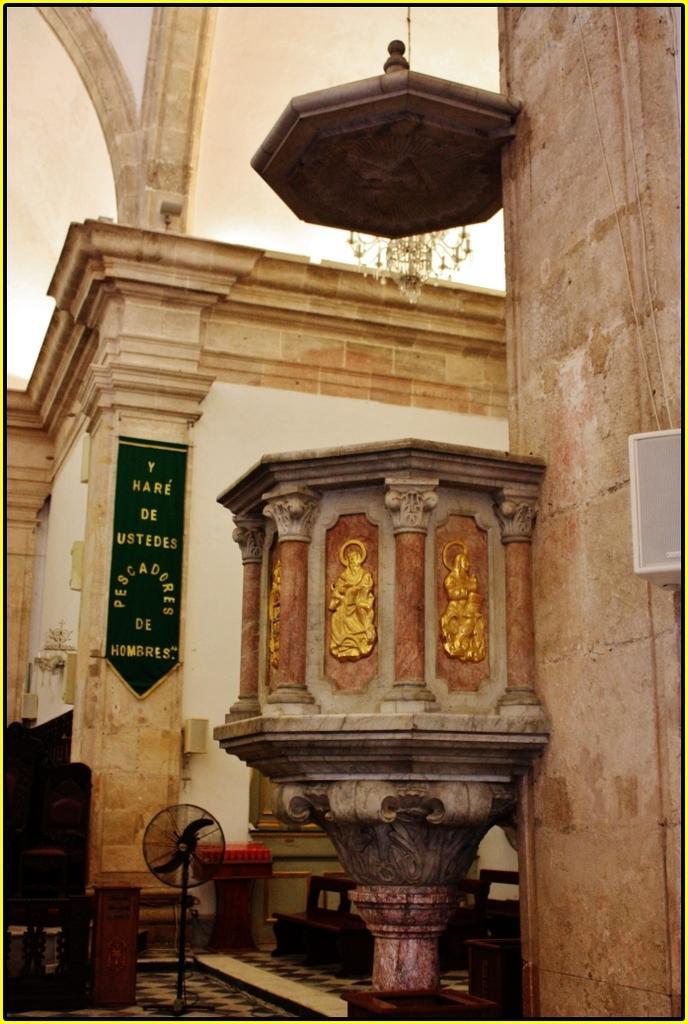Could you give a brief overview of what you see in this image? In this image I can see a wall with some carvings on it. I can see a table fan. There is some text on the wall. 